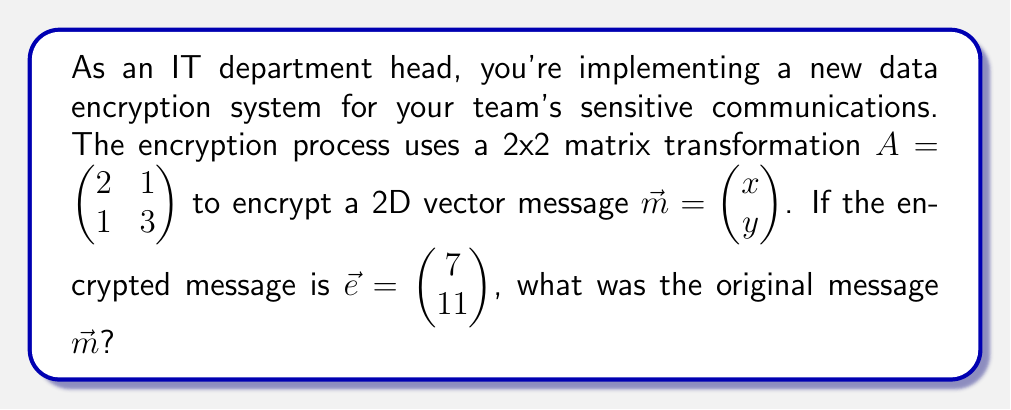Could you help me with this problem? To solve this problem, we'll follow these steps:

1) The encryption process is modeled by the equation:
   $A\vec{m} = \vec{e}$

2) Expanding this equation:
   $$\begin{pmatrix} 2 & 1 \\ 1 & 3 \end{pmatrix} \begin{pmatrix} x \\ y \end{pmatrix} = \begin{pmatrix} 7 \\ 11 \end{pmatrix}$$

3) This gives us a system of linear equations:
   $2x + y = 7$
   $x + 3y = 11$

4) To decrypt, we need to solve this system. We can use matrix inversion:
   $\vec{m} = A^{-1}\vec{e}$

5) First, let's find $A^{-1}$:
   $det(A) = (2)(3) - (1)(1) = 5$
   $A^{-1} = \frac{1}{5}\begin{pmatrix} 3 & -1 \\ -1 & 2 \end{pmatrix}$

6) Now we can solve for $\vec{m}$:
   $$\vec{m} = \frac{1}{5}\begin{pmatrix} 3 & -1 \\ -1 & 2 \end{pmatrix} \begin{pmatrix} 7 \\ 11 \end{pmatrix}$$

7) Multiplying:
   $$\vec{m} = \frac{1}{5}\begin{pmatrix} (3)(7) + (-1)(11) \\ (-1)(7) + (2)(11) \end{pmatrix} = \frac{1}{5}\begin{pmatrix} 10 \\ 15 \end{pmatrix} = \begin{pmatrix} 2 \\ 3 \end{pmatrix}$$

Therefore, the original message was $\vec{m} = \begin{pmatrix} 2 \\ 3 \end{pmatrix}$.
Answer: $\vec{m} = \begin{pmatrix} 2 \\ 3 \end{pmatrix}$ 